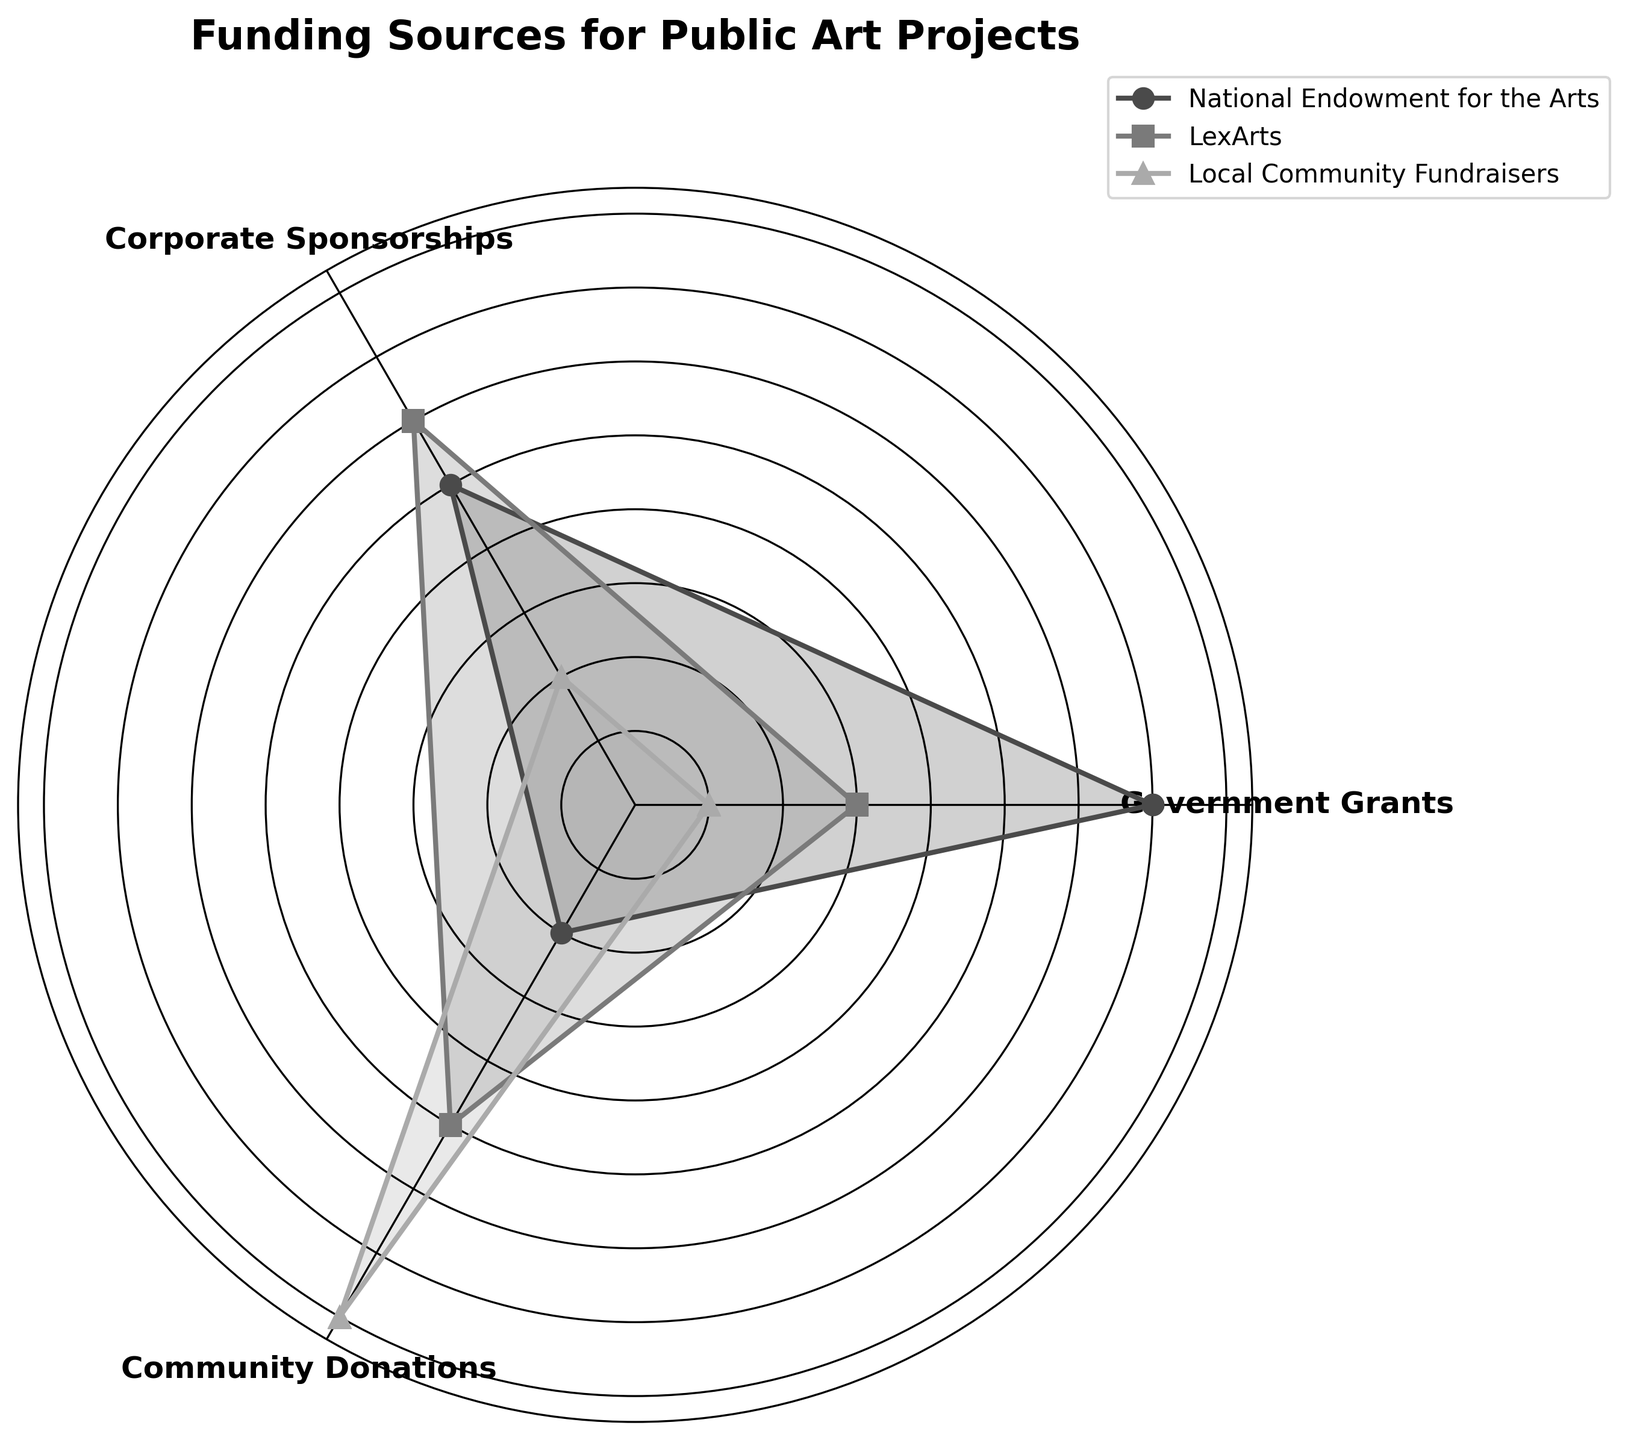What's the title of the radar chart? The title of a chart is usually displayed at the top. In this radar chart, the title is "Funding Sources for Public Art Projects" which informs us about what the chart is illustrating.
Answer: Funding Sources for Public Art Projects How many categories are displayed in the radar chart? By observing the axis labels in the radar chart, you can see that there are labels for Government Grants, Corporate Sponsorships, and Community Donations. This means there are three categories in this radar chart.
Answer: Three Which group has the highest value in the Corporate Sponsorships category? For the Corporate Sponsorships category, you look at the points along the corresponding axis. LexArts reaches the highest point, indicating it has the highest value in this category.
Answer: LexArts What are the values for National Endowment for the Arts and LexArts in the Community Donations category? To determine the values for each group, observe where each line intersects the axis labeled Community Donations. National Endowment for the Arts intersects at 20, and LexArts intersects at 50.
Answer: 20 for National Endowment for the Arts, 50 for LexArts Among the three groups, which one has the smallest value for Government Grants? To find the group with the smallest value for Government Grants, check the positions on the corresponding axis. LexArts has the lowest value of 30, compared to the other groups.
Answer: LexArts What's the average value of Government Grants across the three selected groups? Sum the Government Grants values for National Endowment for the Arts (70), LexArts (30), and Local Community Fundraisers (10). Then divide by the number of groups, which is 3. So (70 + 30 + 10) / 3 = 110 / 3 = 36.67.
Answer: 36.67 Which category shows the highest variance among the three groups? Calculate the range (difference between maximum and minimum values) for each category: Government Grants (70-10=60), Corporate Sponsorships (60-20=40), and Community Donations (80-20=60). The range for Government Grants and Community Donations is both 60, indicating they have the highest variance.
Answer: Government Grants and Community Donations Does Local Community Fundraisers have higher values in Corporate Sponsorships or Community Donations? Compare the values for Local Community Fundraisers in Corporate Sponsorships (20) and Community Donations (80). It has a higher value in Community Donations.
Answer: Community Donations 